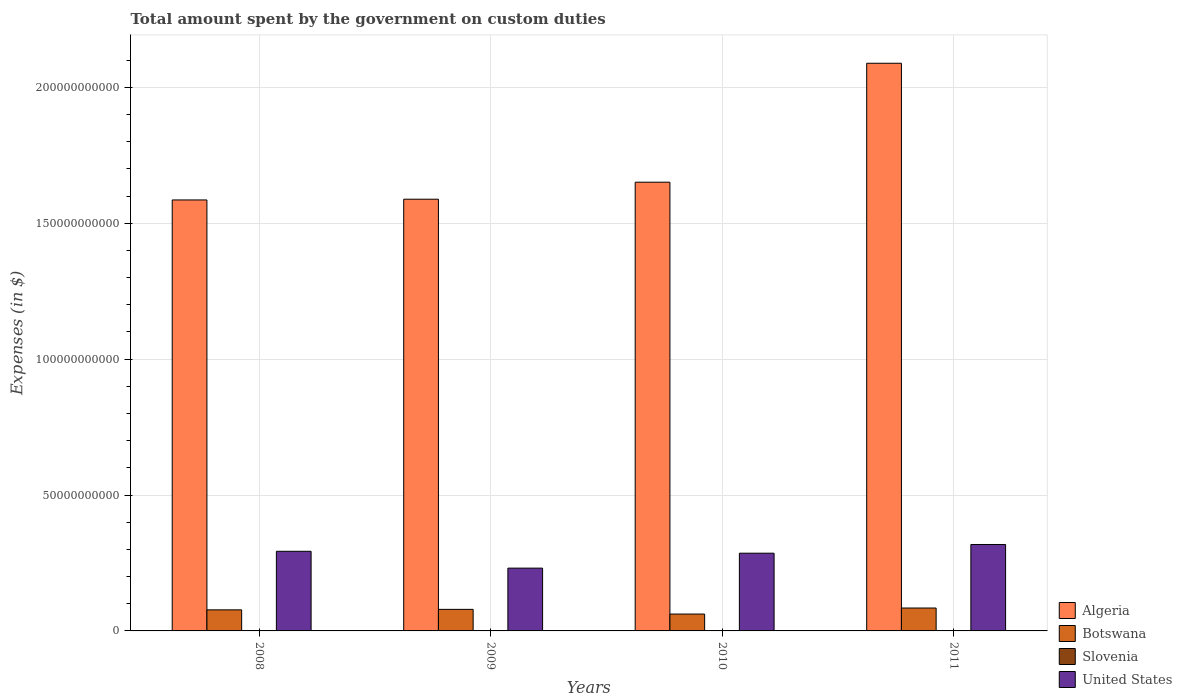How many different coloured bars are there?
Your answer should be very brief. 4. How many groups of bars are there?
Provide a succinct answer. 4. Are the number of bars on each tick of the X-axis equal?
Your response must be concise. Yes. How many bars are there on the 3rd tick from the left?
Offer a terse response. 4. In how many cases, is the number of bars for a given year not equal to the number of legend labels?
Keep it short and to the point. 0. What is the amount spent on custom duties by the government in Algeria in 2011?
Your response must be concise. 2.09e+11. Across all years, what is the maximum amount spent on custom duties by the government in Algeria?
Offer a terse response. 2.09e+11. Across all years, what is the minimum amount spent on custom duties by the government in Botswana?
Your answer should be compact. 6.21e+09. In which year was the amount spent on custom duties by the government in Slovenia maximum?
Give a very brief answer. 2008. In which year was the amount spent on custom duties by the government in Botswana minimum?
Offer a terse response. 2010. What is the total amount spent on custom duties by the government in United States in the graph?
Your answer should be very brief. 1.13e+11. What is the difference between the amount spent on custom duties by the government in Algeria in 2008 and that in 2011?
Make the answer very short. -5.03e+1. What is the difference between the amount spent on custom duties by the government in Botswana in 2011 and the amount spent on custom duties by the government in United States in 2010?
Give a very brief answer. -2.02e+1. What is the average amount spent on custom duties by the government in Algeria per year?
Your response must be concise. 1.73e+11. In the year 2011, what is the difference between the amount spent on custom duties by the government in Slovenia and amount spent on custom duties by the government in Botswana?
Give a very brief answer. -8.40e+09. What is the ratio of the amount spent on custom duties by the government in Slovenia in 2010 to that in 2011?
Give a very brief answer. 0.94. What is the difference between the highest and the second highest amount spent on custom duties by the government in Botswana?
Provide a short and direct response. 4.93e+08. What is the difference between the highest and the lowest amount spent on custom duties by the government in United States?
Your answer should be compact. 8.70e+09. Is the sum of the amount spent on custom duties by the government in United States in 2008 and 2010 greater than the maximum amount spent on custom duties by the government in Botswana across all years?
Offer a very short reply. Yes. What does the 2nd bar from the left in 2008 represents?
Offer a very short reply. Botswana. What does the 1st bar from the right in 2011 represents?
Keep it short and to the point. United States. Is it the case that in every year, the sum of the amount spent on custom duties by the government in Botswana and amount spent on custom duties by the government in Algeria is greater than the amount spent on custom duties by the government in Slovenia?
Ensure brevity in your answer.  Yes. Does the graph contain grids?
Make the answer very short. Yes. Where does the legend appear in the graph?
Your answer should be compact. Bottom right. How many legend labels are there?
Provide a succinct answer. 4. What is the title of the graph?
Provide a succinct answer. Total amount spent by the government on custom duties. What is the label or title of the Y-axis?
Make the answer very short. Expenses (in $). What is the Expenses (in $) of Algeria in 2008?
Provide a short and direct response. 1.59e+11. What is the Expenses (in $) of Botswana in 2008?
Your answer should be compact. 7.75e+09. What is the Expenses (in $) in Slovenia in 2008?
Your answer should be compact. 3.00e+07. What is the Expenses (in $) of United States in 2008?
Provide a short and direct response. 2.93e+1. What is the Expenses (in $) of Algeria in 2009?
Make the answer very short. 1.59e+11. What is the Expenses (in $) in Botswana in 2009?
Offer a terse response. 7.93e+09. What is the Expenses (in $) in Slovenia in 2009?
Provide a succinct answer. 2.13e+07. What is the Expenses (in $) of United States in 2009?
Offer a very short reply. 2.31e+1. What is the Expenses (in $) of Algeria in 2010?
Make the answer very short. 1.65e+11. What is the Expenses (in $) of Botswana in 2010?
Keep it short and to the point. 6.21e+09. What is the Expenses (in $) of Slovenia in 2010?
Offer a terse response. 2.42e+07. What is the Expenses (in $) of United States in 2010?
Offer a very short reply. 2.86e+1. What is the Expenses (in $) of Algeria in 2011?
Your answer should be compact. 2.09e+11. What is the Expenses (in $) of Botswana in 2011?
Provide a succinct answer. 8.42e+09. What is the Expenses (in $) of Slovenia in 2011?
Your response must be concise. 2.58e+07. What is the Expenses (in $) of United States in 2011?
Provide a succinct answer. 3.18e+1. Across all years, what is the maximum Expenses (in $) of Algeria?
Your answer should be compact. 2.09e+11. Across all years, what is the maximum Expenses (in $) of Botswana?
Your answer should be compact. 8.42e+09. Across all years, what is the maximum Expenses (in $) of Slovenia?
Keep it short and to the point. 3.00e+07. Across all years, what is the maximum Expenses (in $) in United States?
Give a very brief answer. 3.18e+1. Across all years, what is the minimum Expenses (in $) of Algeria?
Provide a succinct answer. 1.59e+11. Across all years, what is the minimum Expenses (in $) of Botswana?
Provide a short and direct response. 6.21e+09. Across all years, what is the minimum Expenses (in $) of Slovenia?
Provide a short and direct response. 2.13e+07. Across all years, what is the minimum Expenses (in $) of United States?
Ensure brevity in your answer.  2.31e+1. What is the total Expenses (in $) of Algeria in the graph?
Your answer should be very brief. 6.91e+11. What is the total Expenses (in $) in Botswana in the graph?
Your response must be concise. 3.03e+1. What is the total Expenses (in $) in Slovenia in the graph?
Ensure brevity in your answer.  1.01e+08. What is the total Expenses (in $) of United States in the graph?
Ensure brevity in your answer.  1.13e+11. What is the difference between the Expenses (in $) in Algeria in 2008 and that in 2009?
Make the answer very short. -2.69e+08. What is the difference between the Expenses (in $) of Botswana in 2008 and that in 2009?
Provide a succinct answer. -1.81e+08. What is the difference between the Expenses (in $) of Slovenia in 2008 and that in 2009?
Your response must be concise. 8.73e+06. What is the difference between the Expenses (in $) in United States in 2008 and that in 2009?
Keep it short and to the point. 6.20e+09. What is the difference between the Expenses (in $) in Algeria in 2008 and that in 2010?
Keep it short and to the point. -6.53e+09. What is the difference between the Expenses (in $) in Botswana in 2008 and that in 2010?
Make the answer very short. 1.54e+09. What is the difference between the Expenses (in $) of Slovenia in 2008 and that in 2010?
Your response must be concise. 5.86e+06. What is the difference between the Expenses (in $) of United States in 2008 and that in 2010?
Offer a very short reply. 7.00e+08. What is the difference between the Expenses (in $) of Algeria in 2008 and that in 2011?
Offer a very short reply. -5.03e+1. What is the difference between the Expenses (in $) in Botswana in 2008 and that in 2011?
Your answer should be very brief. -6.74e+08. What is the difference between the Expenses (in $) of Slovenia in 2008 and that in 2011?
Offer a very short reply. 4.26e+06. What is the difference between the Expenses (in $) in United States in 2008 and that in 2011?
Make the answer very short. -2.50e+09. What is the difference between the Expenses (in $) in Algeria in 2009 and that in 2010?
Offer a very short reply. -6.26e+09. What is the difference between the Expenses (in $) in Botswana in 2009 and that in 2010?
Your response must be concise. 1.72e+09. What is the difference between the Expenses (in $) in Slovenia in 2009 and that in 2010?
Your answer should be very brief. -2.88e+06. What is the difference between the Expenses (in $) of United States in 2009 and that in 2010?
Offer a terse response. -5.50e+09. What is the difference between the Expenses (in $) in Algeria in 2009 and that in 2011?
Keep it short and to the point. -5.00e+1. What is the difference between the Expenses (in $) of Botswana in 2009 and that in 2011?
Offer a very short reply. -4.93e+08. What is the difference between the Expenses (in $) of Slovenia in 2009 and that in 2011?
Give a very brief answer. -4.47e+06. What is the difference between the Expenses (in $) of United States in 2009 and that in 2011?
Provide a short and direct response. -8.70e+09. What is the difference between the Expenses (in $) of Algeria in 2010 and that in 2011?
Provide a short and direct response. -4.38e+1. What is the difference between the Expenses (in $) of Botswana in 2010 and that in 2011?
Provide a succinct answer. -2.22e+09. What is the difference between the Expenses (in $) in Slovenia in 2010 and that in 2011?
Keep it short and to the point. -1.60e+06. What is the difference between the Expenses (in $) of United States in 2010 and that in 2011?
Give a very brief answer. -3.20e+09. What is the difference between the Expenses (in $) of Algeria in 2008 and the Expenses (in $) of Botswana in 2009?
Keep it short and to the point. 1.51e+11. What is the difference between the Expenses (in $) in Algeria in 2008 and the Expenses (in $) in Slovenia in 2009?
Provide a succinct answer. 1.59e+11. What is the difference between the Expenses (in $) in Algeria in 2008 and the Expenses (in $) in United States in 2009?
Offer a terse response. 1.35e+11. What is the difference between the Expenses (in $) in Botswana in 2008 and the Expenses (in $) in Slovenia in 2009?
Keep it short and to the point. 7.73e+09. What is the difference between the Expenses (in $) of Botswana in 2008 and the Expenses (in $) of United States in 2009?
Make the answer very short. -1.53e+1. What is the difference between the Expenses (in $) in Slovenia in 2008 and the Expenses (in $) in United States in 2009?
Offer a very short reply. -2.31e+1. What is the difference between the Expenses (in $) of Algeria in 2008 and the Expenses (in $) of Botswana in 2010?
Your response must be concise. 1.52e+11. What is the difference between the Expenses (in $) in Algeria in 2008 and the Expenses (in $) in Slovenia in 2010?
Provide a succinct answer. 1.59e+11. What is the difference between the Expenses (in $) in Algeria in 2008 and the Expenses (in $) in United States in 2010?
Ensure brevity in your answer.  1.30e+11. What is the difference between the Expenses (in $) of Botswana in 2008 and the Expenses (in $) of Slovenia in 2010?
Your answer should be very brief. 7.73e+09. What is the difference between the Expenses (in $) of Botswana in 2008 and the Expenses (in $) of United States in 2010?
Your response must be concise. -2.08e+1. What is the difference between the Expenses (in $) of Slovenia in 2008 and the Expenses (in $) of United States in 2010?
Offer a very short reply. -2.86e+1. What is the difference between the Expenses (in $) of Algeria in 2008 and the Expenses (in $) of Botswana in 2011?
Your answer should be compact. 1.50e+11. What is the difference between the Expenses (in $) of Algeria in 2008 and the Expenses (in $) of Slovenia in 2011?
Your answer should be very brief. 1.59e+11. What is the difference between the Expenses (in $) in Algeria in 2008 and the Expenses (in $) in United States in 2011?
Make the answer very short. 1.27e+11. What is the difference between the Expenses (in $) of Botswana in 2008 and the Expenses (in $) of Slovenia in 2011?
Your answer should be compact. 7.72e+09. What is the difference between the Expenses (in $) of Botswana in 2008 and the Expenses (in $) of United States in 2011?
Offer a very short reply. -2.40e+1. What is the difference between the Expenses (in $) in Slovenia in 2008 and the Expenses (in $) in United States in 2011?
Your response must be concise. -3.18e+1. What is the difference between the Expenses (in $) of Algeria in 2009 and the Expenses (in $) of Botswana in 2010?
Give a very brief answer. 1.53e+11. What is the difference between the Expenses (in $) of Algeria in 2009 and the Expenses (in $) of Slovenia in 2010?
Give a very brief answer. 1.59e+11. What is the difference between the Expenses (in $) in Algeria in 2009 and the Expenses (in $) in United States in 2010?
Your response must be concise. 1.30e+11. What is the difference between the Expenses (in $) of Botswana in 2009 and the Expenses (in $) of Slovenia in 2010?
Your answer should be very brief. 7.91e+09. What is the difference between the Expenses (in $) in Botswana in 2009 and the Expenses (in $) in United States in 2010?
Your response must be concise. -2.07e+1. What is the difference between the Expenses (in $) in Slovenia in 2009 and the Expenses (in $) in United States in 2010?
Provide a short and direct response. -2.86e+1. What is the difference between the Expenses (in $) of Algeria in 2009 and the Expenses (in $) of Botswana in 2011?
Make the answer very short. 1.50e+11. What is the difference between the Expenses (in $) of Algeria in 2009 and the Expenses (in $) of Slovenia in 2011?
Offer a very short reply. 1.59e+11. What is the difference between the Expenses (in $) of Algeria in 2009 and the Expenses (in $) of United States in 2011?
Keep it short and to the point. 1.27e+11. What is the difference between the Expenses (in $) in Botswana in 2009 and the Expenses (in $) in Slovenia in 2011?
Keep it short and to the point. 7.91e+09. What is the difference between the Expenses (in $) in Botswana in 2009 and the Expenses (in $) in United States in 2011?
Provide a succinct answer. -2.39e+1. What is the difference between the Expenses (in $) in Slovenia in 2009 and the Expenses (in $) in United States in 2011?
Keep it short and to the point. -3.18e+1. What is the difference between the Expenses (in $) in Algeria in 2010 and the Expenses (in $) in Botswana in 2011?
Give a very brief answer. 1.57e+11. What is the difference between the Expenses (in $) in Algeria in 2010 and the Expenses (in $) in Slovenia in 2011?
Provide a short and direct response. 1.65e+11. What is the difference between the Expenses (in $) of Algeria in 2010 and the Expenses (in $) of United States in 2011?
Offer a very short reply. 1.33e+11. What is the difference between the Expenses (in $) in Botswana in 2010 and the Expenses (in $) in Slovenia in 2011?
Keep it short and to the point. 6.18e+09. What is the difference between the Expenses (in $) in Botswana in 2010 and the Expenses (in $) in United States in 2011?
Offer a very short reply. -2.56e+1. What is the difference between the Expenses (in $) of Slovenia in 2010 and the Expenses (in $) of United States in 2011?
Ensure brevity in your answer.  -3.18e+1. What is the average Expenses (in $) in Algeria per year?
Ensure brevity in your answer.  1.73e+11. What is the average Expenses (in $) of Botswana per year?
Your answer should be compact. 7.58e+09. What is the average Expenses (in $) of Slovenia per year?
Give a very brief answer. 2.53e+07. What is the average Expenses (in $) of United States per year?
Your answer should be very brief. 2.82e+1. In the year 2008, what is the difference between the Expenses (in $) in Algeria and Expenses (in $) in Botswana?
Your answer should be compact. 1.51e+11. In the year 2008, what is the difference between the Expenses (in $) in Algeria and Expenses (in $) in Slovenia?
Your answer should be compact. 1.59e+11. In the year 2008, what is the difference between the Expenses (in $) of Algeria and Expenses (in $) of United States?
Offer a terse response. 1.29e+11. In the year 2008, what is the difference between the Expenses (in $) in Botswana and Expenses (in $) in Slovenia?
Your answer should be compact. 7.72e+09. In the year 2008, what is the difference between the Expenses (in $) of Botswana and Expenses (in $) of United States?
Keep it short and to the point. -2.15e+1. In the year 2008, what is the difference between the Expenses (in $) of Slovenia and Expenses (in $) of United States?
Your answer should be very brief. -2.93e+1. In the year 2009, what is the difference between the Expenses (in $) in Algeria and Expenses (in $) in Botswana?
Offer a terse response. 1.51e+11. In the year 2009, what is the difference between the Expenses (in $) of Algeria and Expenses (in $) of Slovenia?
Your response must be concise. 1.59e+11. In the year 2009, what is the difference between the Expenses (in $) in Algeria and Expenses (in $) in United States?
Provide a succinct answer. 1.36e+11. In the year 2009, what is the difference between the Expenses (in $) in Botswana and Expenses (in $) in Slovenia?
Your response must be concise. 7.91e+09. In the year 2009, what is the difference between the Expenses (in $) of Botswana and Expenses (in $) of United States?
Offer a terse response. -1.52e+1. In the year 2009, what is the difference between the Expenses (in $) in Slovenia and Expenses (in $) in United States?
Provide a succinct answer. -2.31e+1. In the year 2010, what is the difference between the Expenses (in $) of Algeria and Expenses (in $) of Botswana?
Your answer should be compact. 1.59e+11. In the year 2010, what is the difference between the Expenses (in $) in Algeria and Expenses (in $) in Slovenia?
Ensure brevity in your answer.  1.65e+11. In the year 2010, what is the difference between the Expenses (in $) in Algeria and Expenses (in $) in United States?
Your response must be concise. 1.36e+11. In the year 2010, what is the difference between the Expenses (in $) in Botswana and Expenses (in $) in Slovenia?
Ensure brevity in your answer.  6.18e+09. In the year 2010, what is the difference between the Expenses (in $) in Botswana and Expenses (in $) in United States?
Provide a short and direct response. -2.24e+1. In the year 2010, what is the difference between the Expenses (in $) in Slovenia and Expenses (in $) in United States?
Your answer should be compact. -2.86e+1. In the year 2011, what is the difference between the Expenses (in $) of Algeria and Expenses (in $) of Botswana?
Your response must be concise. 2.00e+11. In the year 2011, what is the difference between the Expenses (in $) of Algeria and Expenses (in $) of Slovenia?
Keep it short and to the point. 2.09e+11. In the year 2011, what is the difference between the Expenses (in $) of Algeria and Expenses (in $) of United States?
Offer a terse response. 1.77e+11. In the year 2011, what is the difference between the Expenses (in $) of Botswana and Expenses (in $) of Slovenia?
Keep it short and to the point. 8.40e+09. In the year 2011, what is the difference between the Expenses (in $) of Botswana and Expenses (in $) of United States?
Your answer should be very brief. -2.34e+1. In the year 2011, what is the difference between the Expenses (in $) in Slovenia and Expenses (in $) in United States?
Give a very brief answer. -3.18e+1. What is the ratio of the Expenses (in $) of Algeria in 2008 to that in 2009?
Your answer should be compact. 1. What is the ratio of the Expenses (in $) in Botswana in 2008 to that in 2009?
Your response must be concise. 0.98. What is the ratio of the Expenses (in $) of Slovenia in 2008 to that in 2009?
Give a very brief answer. 1.41. What is the ratio of the Expenses (in $) of United States in 2008 to that in 2009?
Offer a very short reply. 1.27. What is the ratio of the Expenses (in $) in Algeria in 2008 to that in 2010?
Provide a short and direct response. 0.96. What is the ratio of the Expenses (in $) of Botswana in 2008 to that in 2010?
Your answer should be very brief. 1.25. What is the ratio of the Expenses (in $) in Slovenia in 2008 to that in 2010?
Keep it short and to the point. 1.24. What is the ratio of the Expenses (in $) in United States in 2008 to that in 2010?
Provide a succinct answer. 1.02. What is the ratio of the Expenses (in $) in Algeria in 2008 to that in 2011?
Your answer should be compact. 0.76. What is the ratio of the Expenses (in $) of Slovenia in 2008 to that in 2011?
Offer a very short reply. 1.17. What is the ratio of the Expenses (in $) in United States in 2008 to that in 2011?
Ensure brevity in your answer.  0.92. What is the ratio of the Expenses (in $) in Algeria in 2009 to that in 2010?
Your answer should be compact. 0.96. What is the ratio of the Expenses (in $) in Botswana in 2009 to that in 2010?
Offer a terse response. 1.28. What is the ratio of the Expenses (in $) in Slovenia in 2009 to that in 2010?
Make the answer very short. 0.88. What is the ratio of the Expenses (in $) of United States in 2009 to that in 2010?
Your answer should be very brief. 0.81. What is the ratio of the Expenses (in $) of Algeria in 2009 to that in 2011?
Provide a short and direct response. 0.76. What is the ratio of the Expenses (in $) in Botswana in 2009 to that in 2011?
Your answer should be very brief. 0.94. What is the ratio of the Expenses (in $) of Slovenia in 2009 to that in 2011?
Offer a terse response. 0.83. What is the ratio of the Expenses (in $) in United States in 2009 to that in 2011?
Make the answer very short. 0.73. What is the ratio of the Expenses (in $) in Algeria in 2010 to that in 2011?
Your answer should be very brief. 0.79. What is the ratio of the Expenses (in $) of Botswana in 2010 to that in 2011?
Provide a short and direct response. 0.74. What is the ratio of the Expenses (in $) in Slovenia in 2010 to that in 2011?
Your answer should be compact. 0.94. What is the ratio of the Expenses (in $) in United States in 2010 to that in 2011?
Your answer should be very brief. 0.9. What is the difference between the highest and the second highest Expenses (in $) in Algeria?
Provide a short and direct response. 4.38e+1. What is the difference between the highest and the second highest Expenses (in $) of Botswana?
Offer a terse response. 4.93e+08. What is the difference between the highest and the second highest Expenses (in $) of Slovenia?
Offer a very short reply. 4.26e+06. What is the difference between the highest and the second highest Expenses (in $) of United States?
Make the answer very short. 2.50e+09. What is the difference between the highest and the lowest Expenses (in $) in Algeria?
Ensure brevity in your answer.  5.03e+1. What is the difference between the highest and the lowest Expenses (in $) of Botswana?
Provide a succinct answer. 2.22e+09. What is the difference between the highest and the lowest Expenses (in $) in Slovenia?
Offer a very short reply. 8.73e+06. What is the difference between the highest and the lowest Expenses (in $) of United States?
Your answer should be very brief. 8.70e+09. 